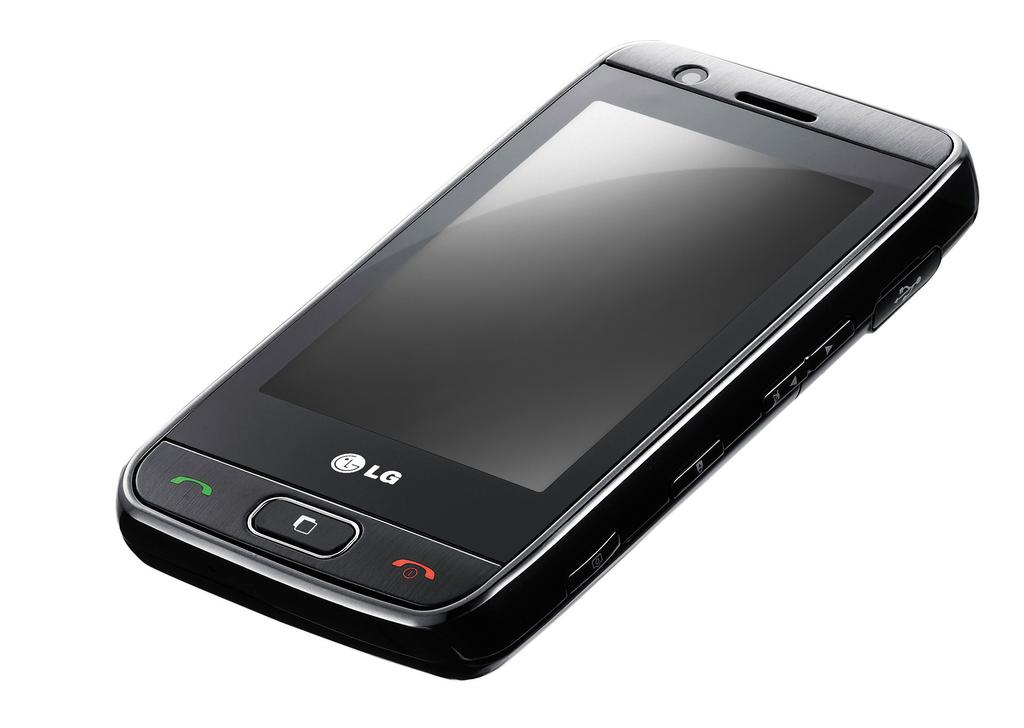<image>
Relay a brief, clear account of the picture shown. A black LG phone is angled up in front of a white background. 